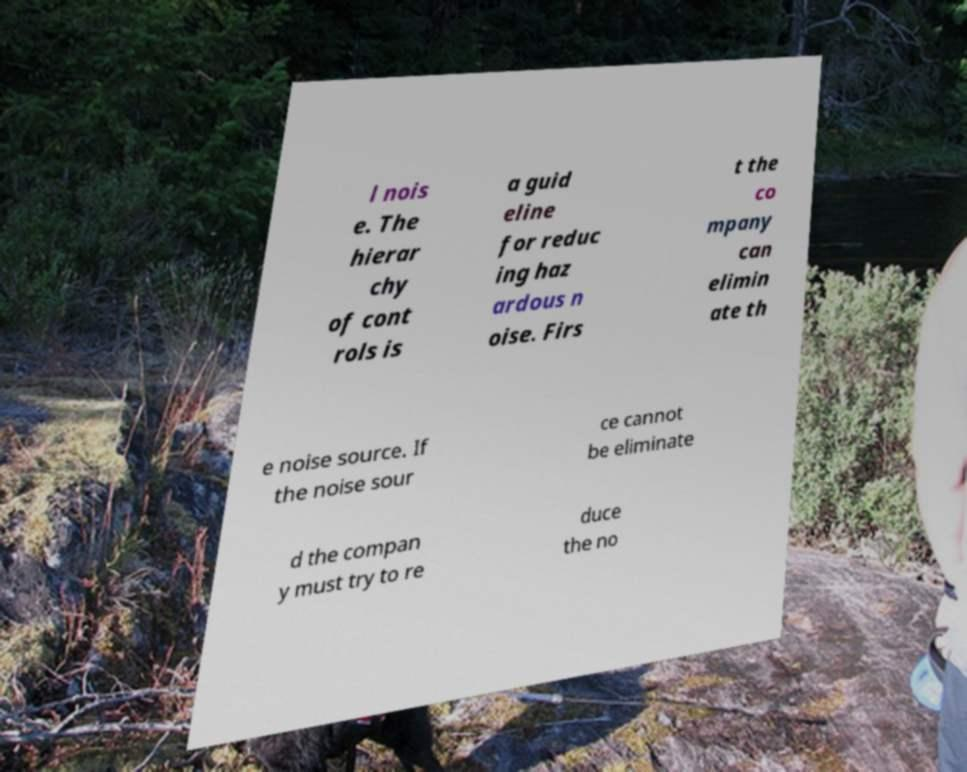For documentation purposes, I need the text within this image transcribed. Could you provide that? l nois e. The hierar chy of cont rols is a guid eline for reduc ing haz ardous n oise. Firs t the co mpany can elimin ate th e noise source. If the noise sour ce cannot be eliminate d the compan y must try to re duce the no 